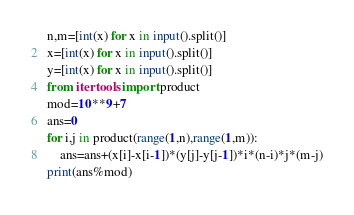<code> <loc_0><loc_0><loc_500><loc_500><_Python_>n,m=[int(x) for x in input().split()]
x=[int(x) for x in input().split()]
y=[int(x) for x in input().split()]
from itertools import product
mod=10**9+7
ans=0
for i,j in product(range(1,n),range(1,m)):
    ans=ans+(x[i]-x[i-1])*(y[j]-y[j-1])*i*(n-i)*j*(m-j)
print(ans%mod)</code> 